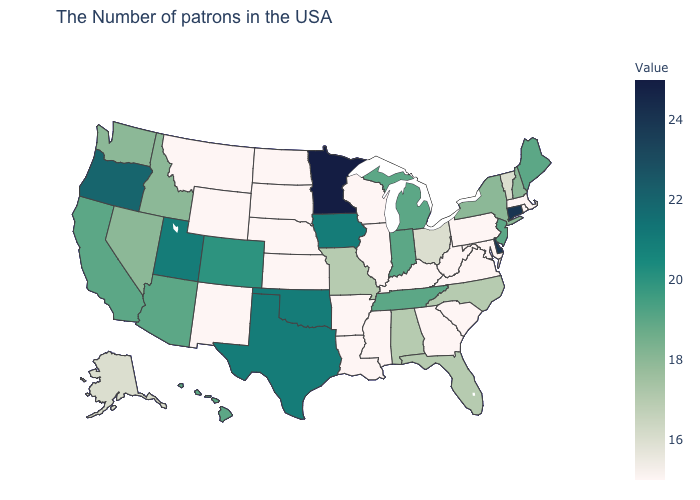Does Louisiana have the highest value in the USA?
Answer briefly. No. Is the legend a continuous bar?
Answer briefly. Yes. Among the states that border Oklahoma , does New Mexico have the lowest value?
Keep it brief. Yes. Among the states that border Ohio , which have the lowest value?
Answer briefly. Pennsylvania, West Virginia, Kentucky. Does Montana have the highest value in the West?
Concise answer only. No. Does the map have missing data?
Quick response, please. No. Does West Virginia have the lowest value in the USA?
Answer briefly. Yes. Does the map have missing data?
Quick response, please. No. Among the states that border Massachusetts , does Rhode Island have the lowest value?
Keep it brief. Yes. 